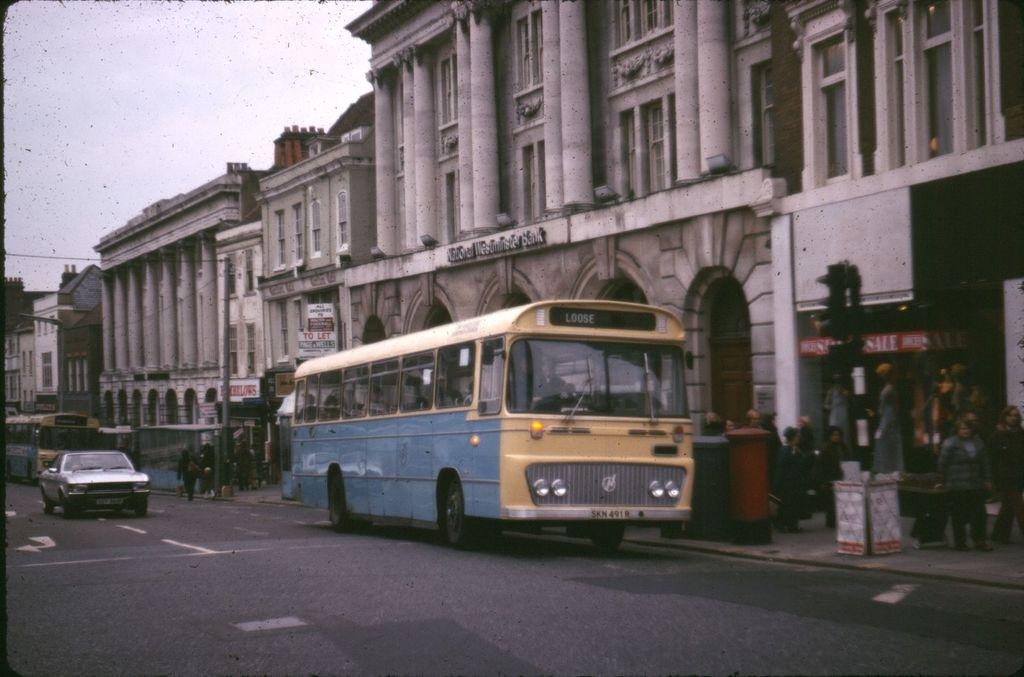What type of vehicle can be seen in the image? There is a car in the image. What other types of vehicles are present on the road in the image? There are buses on the road in the image. What structures can be seen in the image? There are buildings in the image. What are the poles used for in the image? The poles are likely used for supporting wires or signs in the image. What can be seen on the walls of the buildings in the image? There are posters in the image. What objects are present in the image? There are objects in the image, but we cannot identify them specifically without more information. Where are the people located in the image? There is a group of people on the footpath in the image. What is visible in the background of the image? The sky is visible in the background of the image. What type of shirt is being worn by the tent in the image? There is no tent or shirt present in the image. How many sponges can be seen on the car in the image? There are no sponges present in the image. 